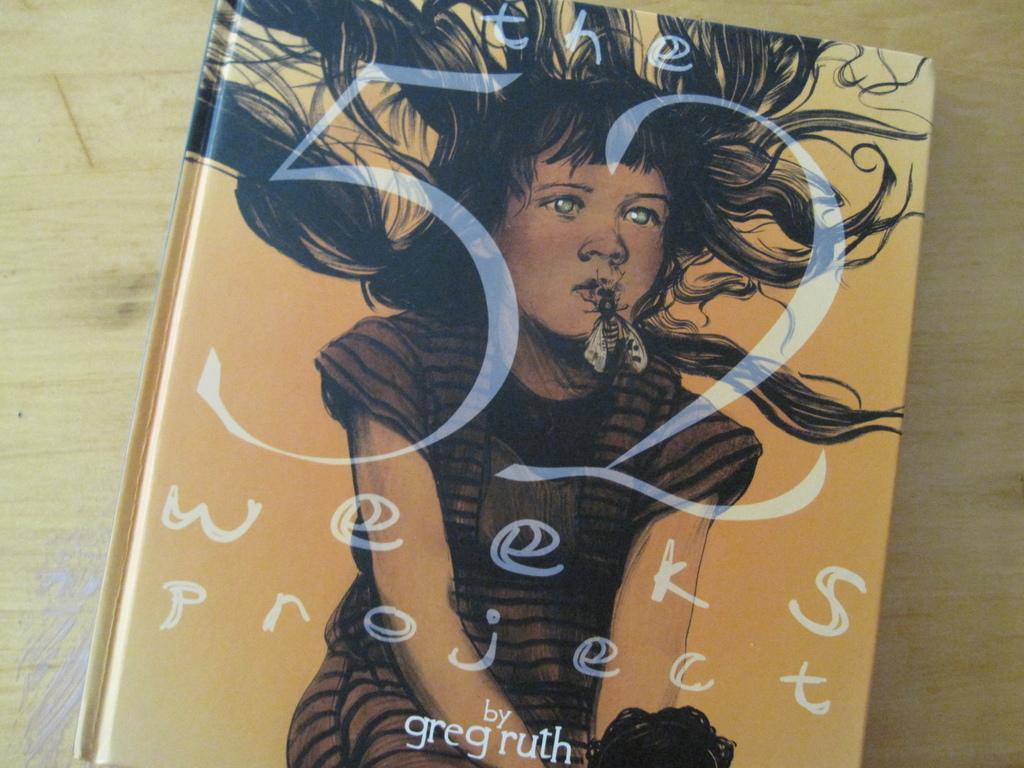Please provide a concise description of this image. In this image we can see a book that is placed on a wooden surface. 